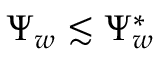Convert formula to latex. <formula><loc_0><loc_0><loc_500><loc_500>\Psi _ { w } \lesssim \Psi _ { w } ^ { * }</formula> 